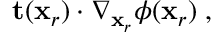<formula> <loc_0><loc_0><loc_500><loc_500>t ( x _ { r } ) \cdot \nabla _ { x _ { r } } \phi ( x _ { r } ) \, ,</formula> 